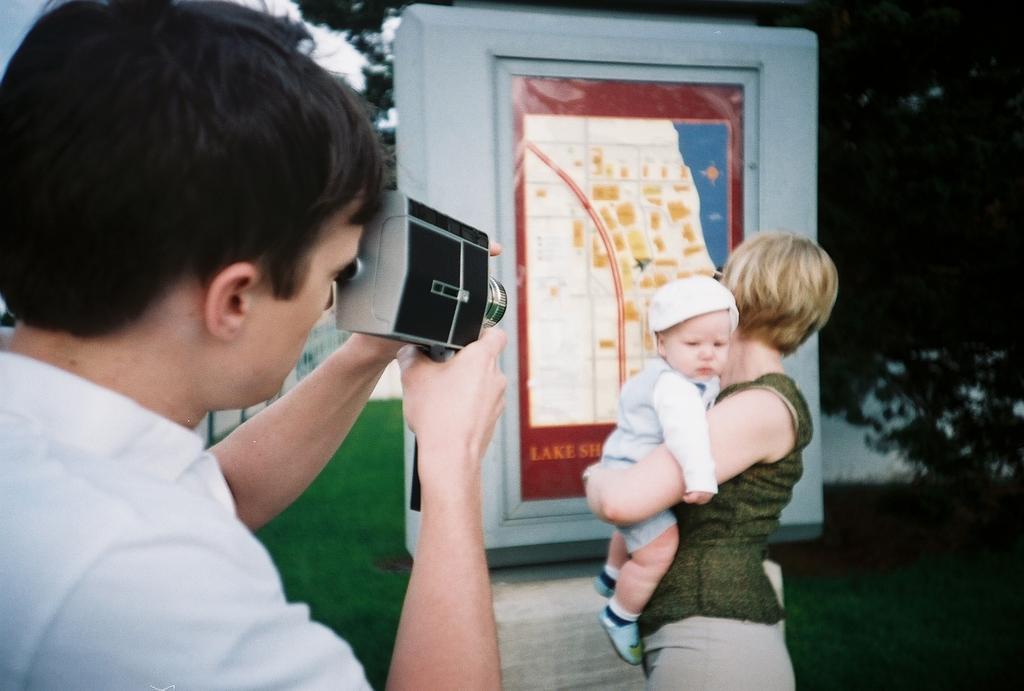In one or two sentences, can you explain what this image depicts? In this image in front there is a person holding the camera. In front of him there is a woman holding the baby. Behind her there is a wall. At the bottom of the image there is grass on the surface. In the background of the image there are trees and sky. 